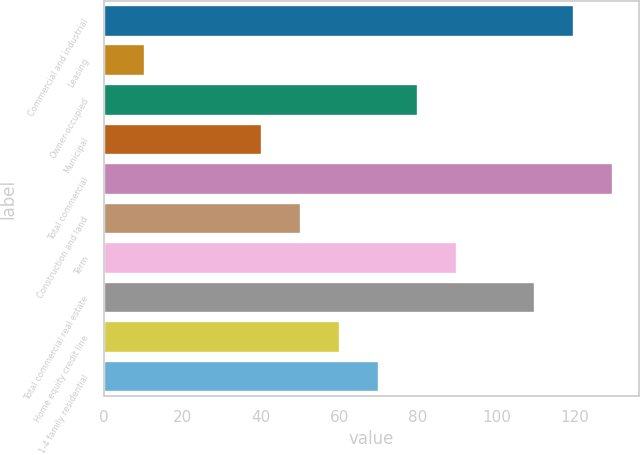Convert chart to OTSL. <chart><loc_0><loc_0><loc_500><loc_500><bar_chart><fcel>Commercial and industrial<fcel>Leasing<fcel>Owner-occupied<fcel>Municipal<fcel>Total commercial<fcel>Construction and land<fcel>Term<fcel>Total commercial real estate<fcel>Home equity credit line<fcel>1-4 family residential<nl><fcel>119.9<fcel>10.45<fcel>80.1<fcel>40.3<fcel>129.85<fcel>50.25<fcel>90.05<fcel>109.95<fcel>60.2<fcel>70.15<nl></chart> 